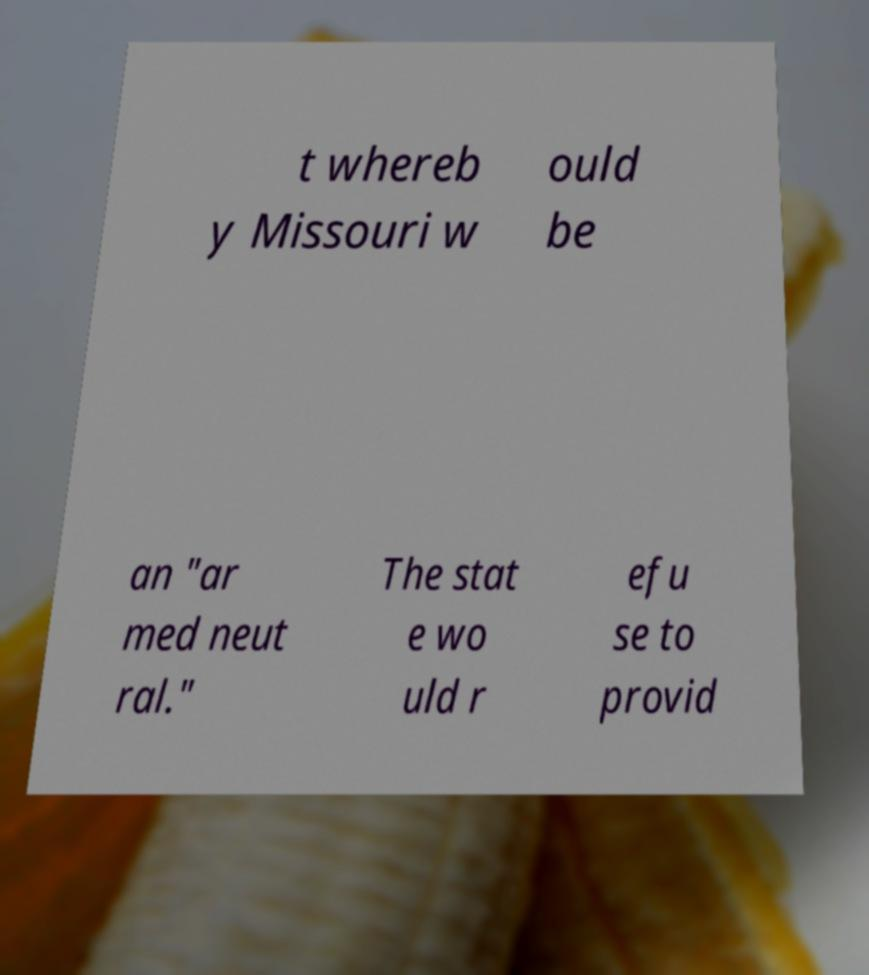Can you accurately transcribe the text from the provided image for me? t whereb y Missouri w ould be an "ar med neut ral." The stat e wo uld r efu se to provid 